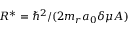<formula> <loc_0><loc_0><loc_500><loc_500>R ^ { * } = \hbar { ^ } { 2 } / ( 2 m _ { r } a _ { 0 } \delta \mu A )</formula> 